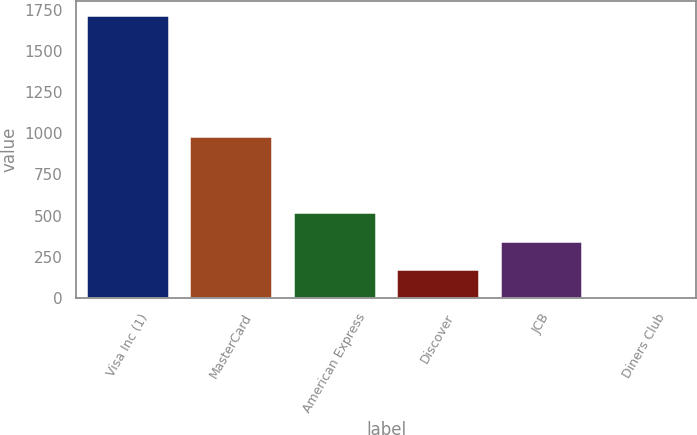Convert chart. <chart><loc_0><loc_0><loc_500><loc_500><bar_chart><fcel>Visa Inc (1)<fcel>MasterCard<fcel>American Express<fcel>Discover<fcel>JCB<fcel>Diners Club<nl><fcel>1717<fcel>981<fcel>520<fcel>178<fcel>349<fcel>7<nl></chart> 